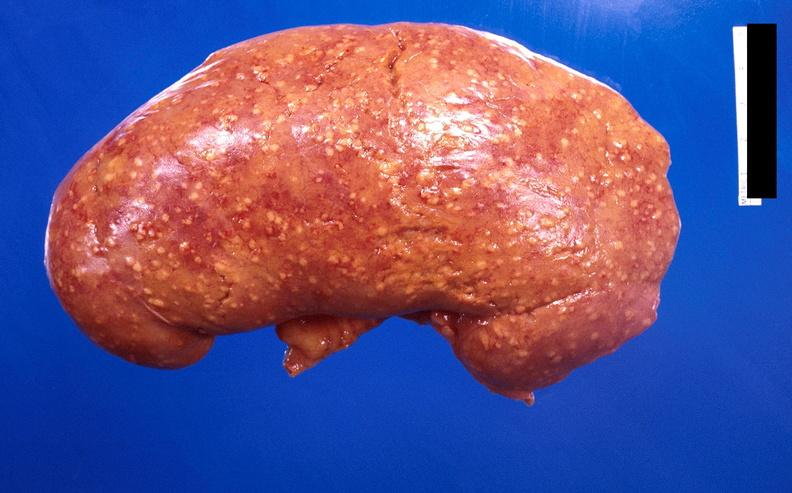does mycobacterium avium intracellulare show kidney, candida abscesses?
Answer the question using a single word or phrase. No 